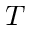<formula> <loc_0><loc_0><loc_500><loc_500>T</formula> 